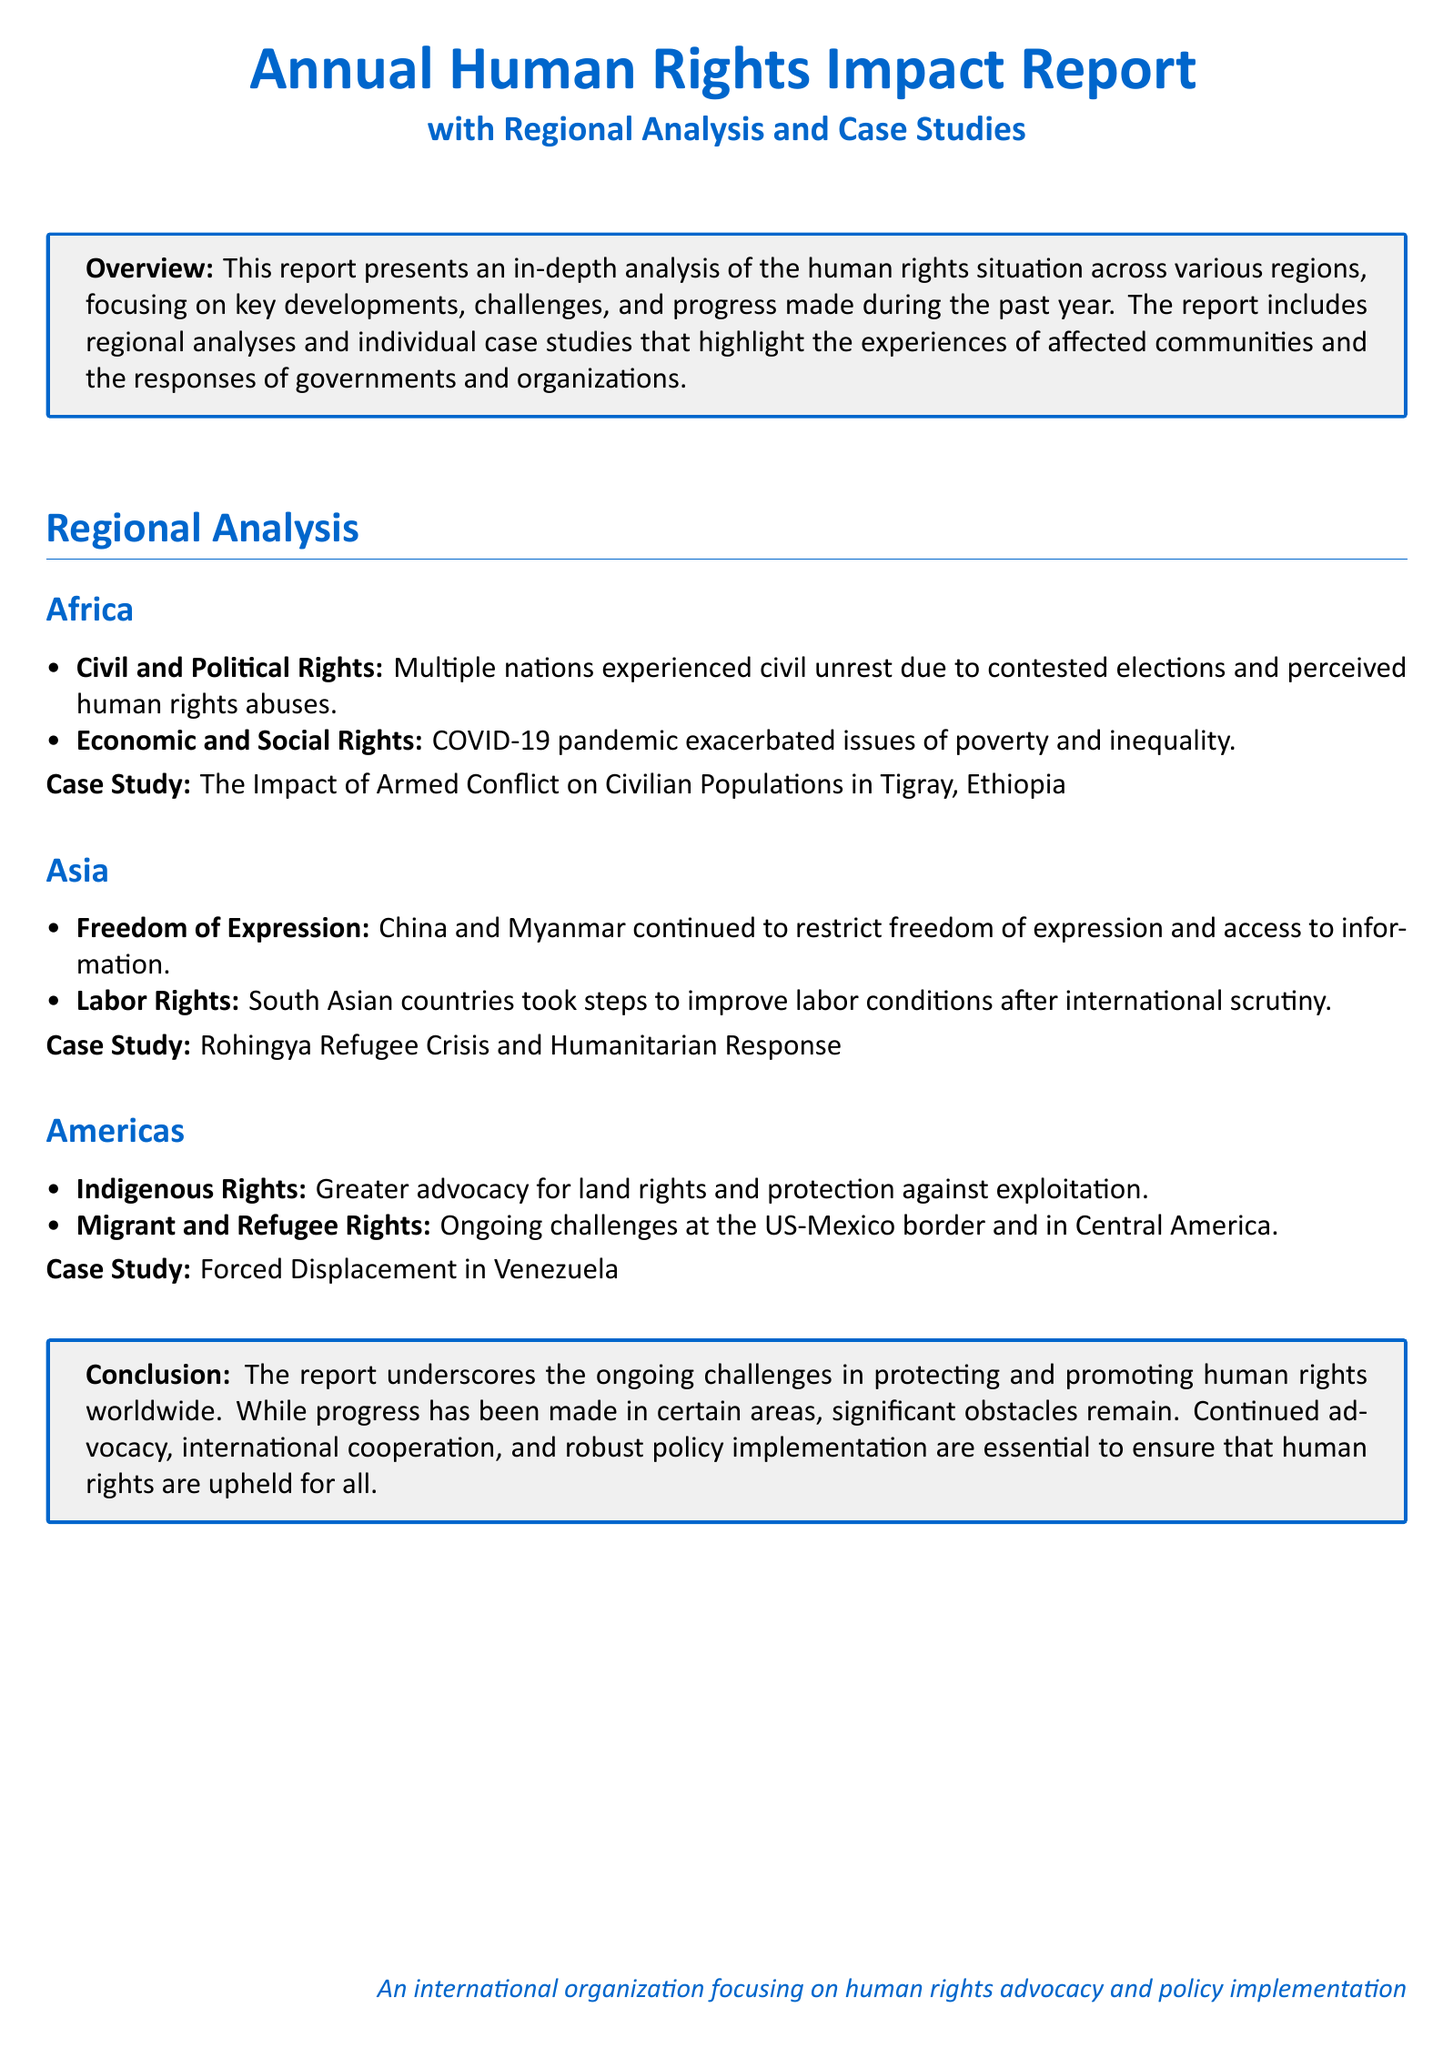What is the title of the report? The title of the report is mentioned at the top of the document in a prominent format.
Answer: Annual Human Rights Impact Report What region does the case study about the Tigray conflict focus on? The case study specifically addresses the impact of armed conflict in Ethiopia, which is in Africa.
Answer: Africa What major rights issue was highlighted in Asia? The report specifically mentions restrictions on freedom of expression in certain countries.
Answer: Freedom of Expression How did the COVID-19 pandemic impact economic rights in Africa? The report notes that the pandemic exacerbated issues of poverty and inequality, indicating a significant impact on economic rights.
Answer: Poverty and inequality What is emphasized as essential for upholding human rights globally? The conclusion of the document states that continued advocacy, international cooperation, and robust policy implementation are essential.
Answer: Advocacy, international cooperation, and robust policy implementation What case study addresses the situation of migrants and refugees in the Americas? In the Americas section, a case study is provided that covers challenges related to migration and refugee rights.
Answer: Forced Displacement in Venezuela 